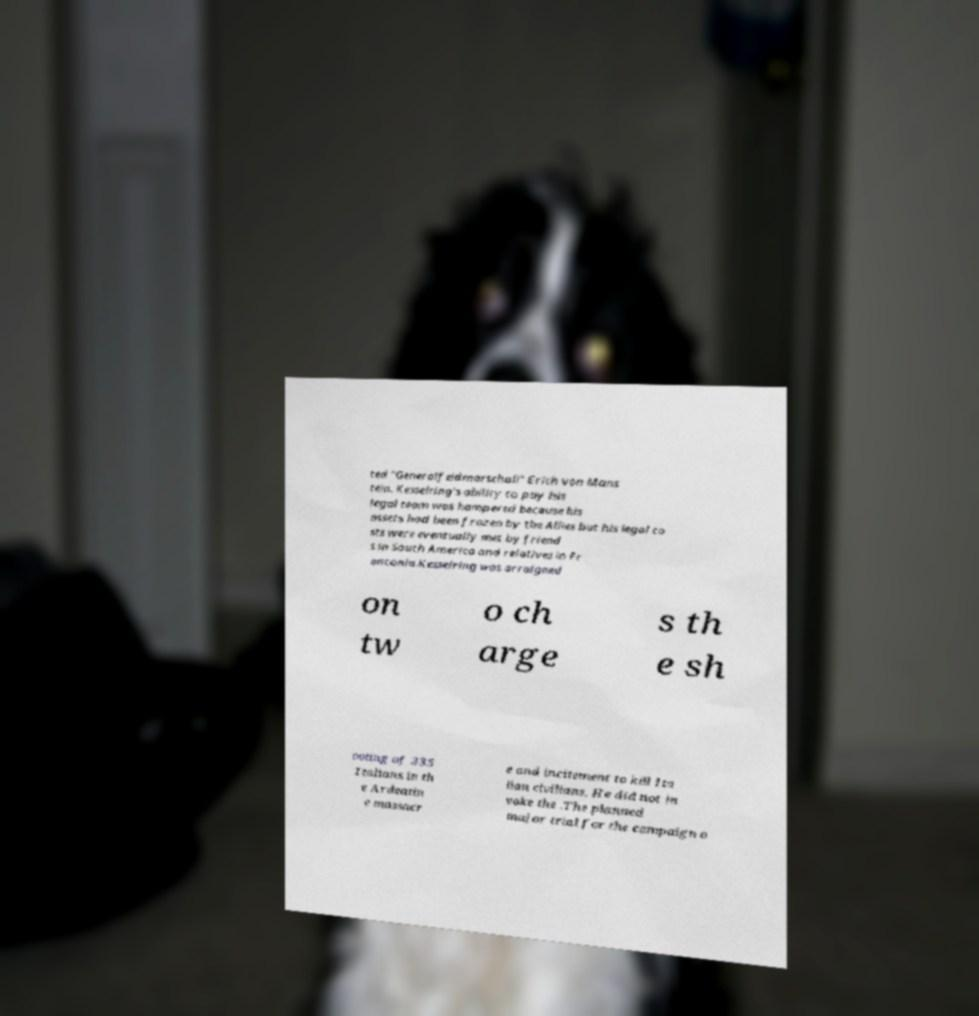Please identify and transcribe the text found in this image. ted "Generalfeldmarschall" Erich von Mans tein. Kesselring's ability to pay his legal team was hampered because his assets had been frozen by the Allies but his legal co sts were eventually met by friend s in South America and relatives in Fr anconia.Kesselring was arraigned on tw o ch arge s th e sh ooting of 335 Italians in th e Ardeatin e massacr e and incitement to kill Ita lian civilians. He did not in voke the .The planned major trial for the campaign o 